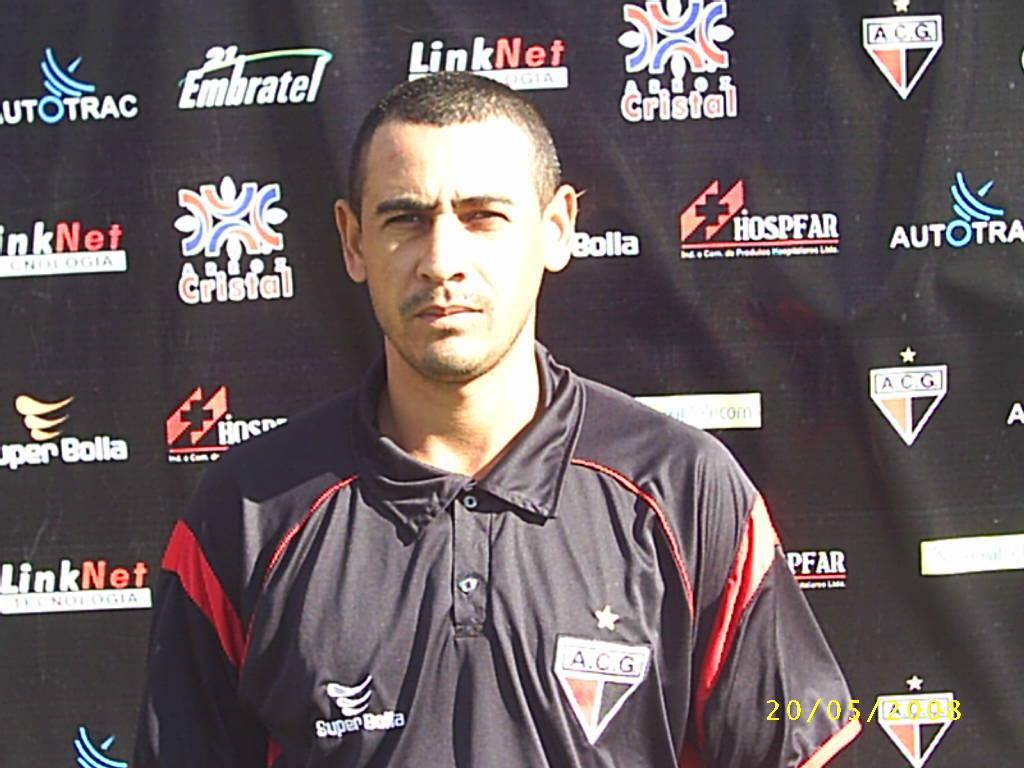<image>
Relay a brief, clear account of the picture shown. the word cristal is on the ad board behind the man 